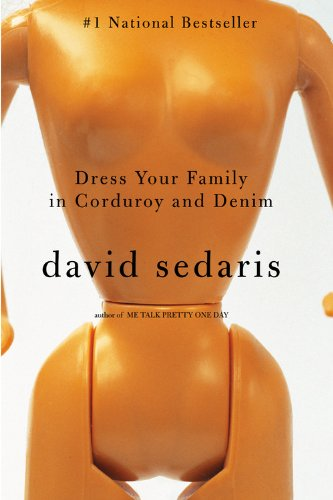What is the title of this book? The title of the book depicted is 'Dress Your Family in Corduroy and Denim,' a bestseller that offers a series of engaging and humorous essays. 